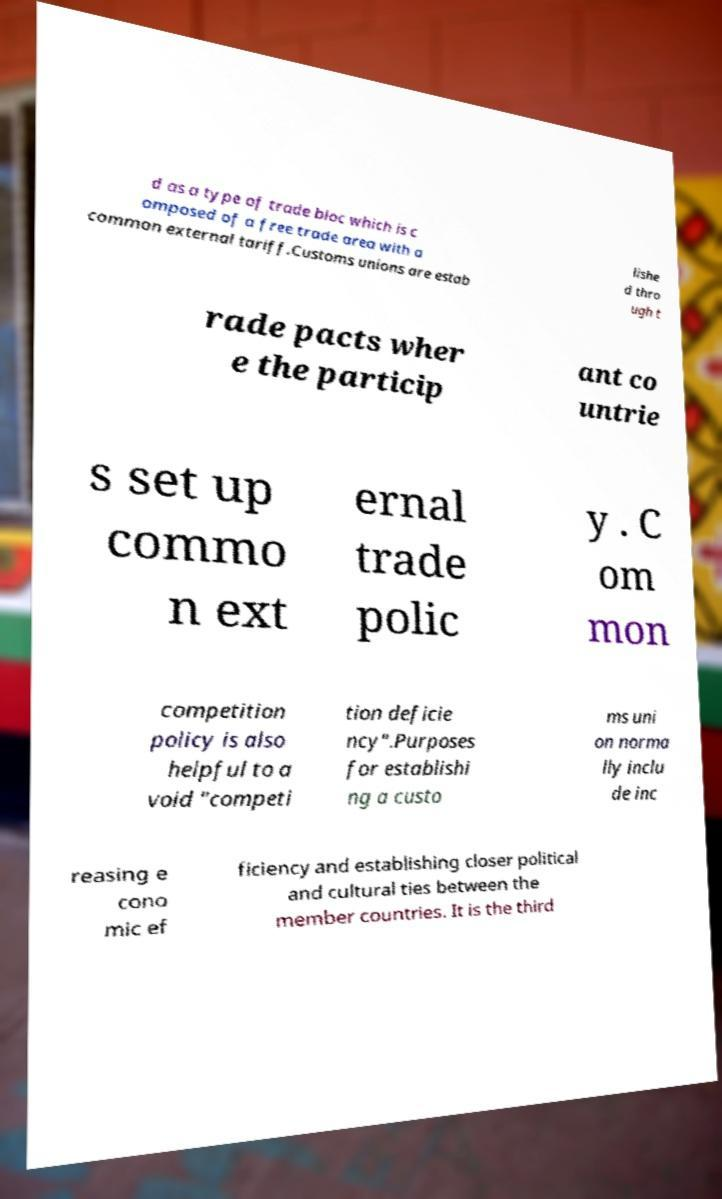Please identify and transcribe the text found in this image. d as a type of trade bloc which is c omposed of a free trade area with a common external tariff.Customs unions are estab lishe d thro ugh t rade pacts wher e the particip ant co untrie s set up commo n ext ernal trade polic y . C om mon competition policy is also helpful to a void "competi tion deficie ncy".Purposes for establishi ng a custo ms uni on norma lly inclu de inc reasing e cono mic ef ficiency and establishing closer political and cultural ties between the member countries. It is the third 